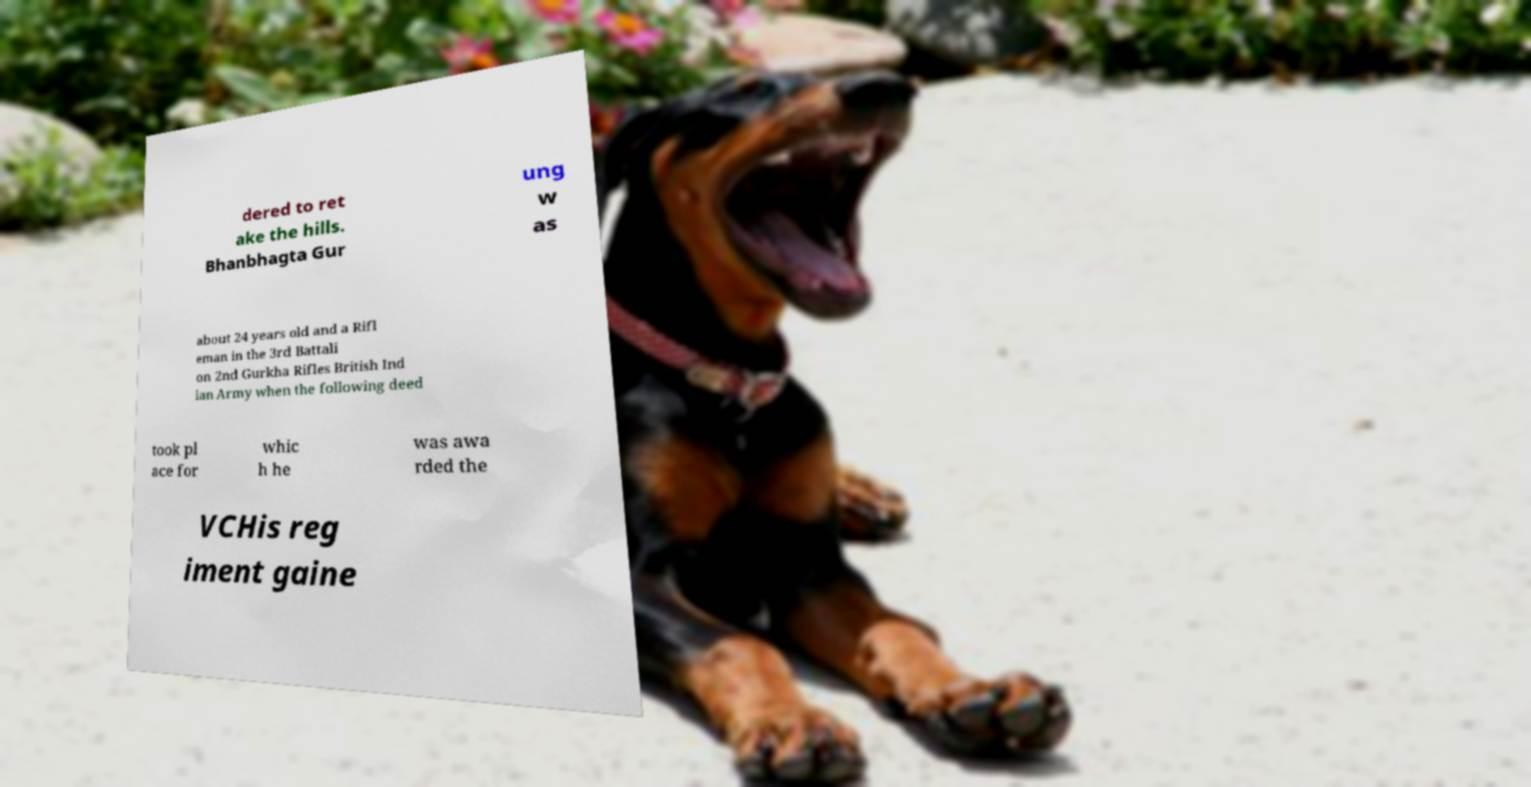There's text embedded in this image that I need extracted. Can you transcribe it verbatim? dered to ret ake the hills. Bhanbhagta Gur ung w as about 24 years old and a Rifl eman in the 3rd Battali on 2nd Gurkha Rifles British Ind ian Army when the following deed took pl ace for whic h he was awa rded the VCHis reg iment gaine 